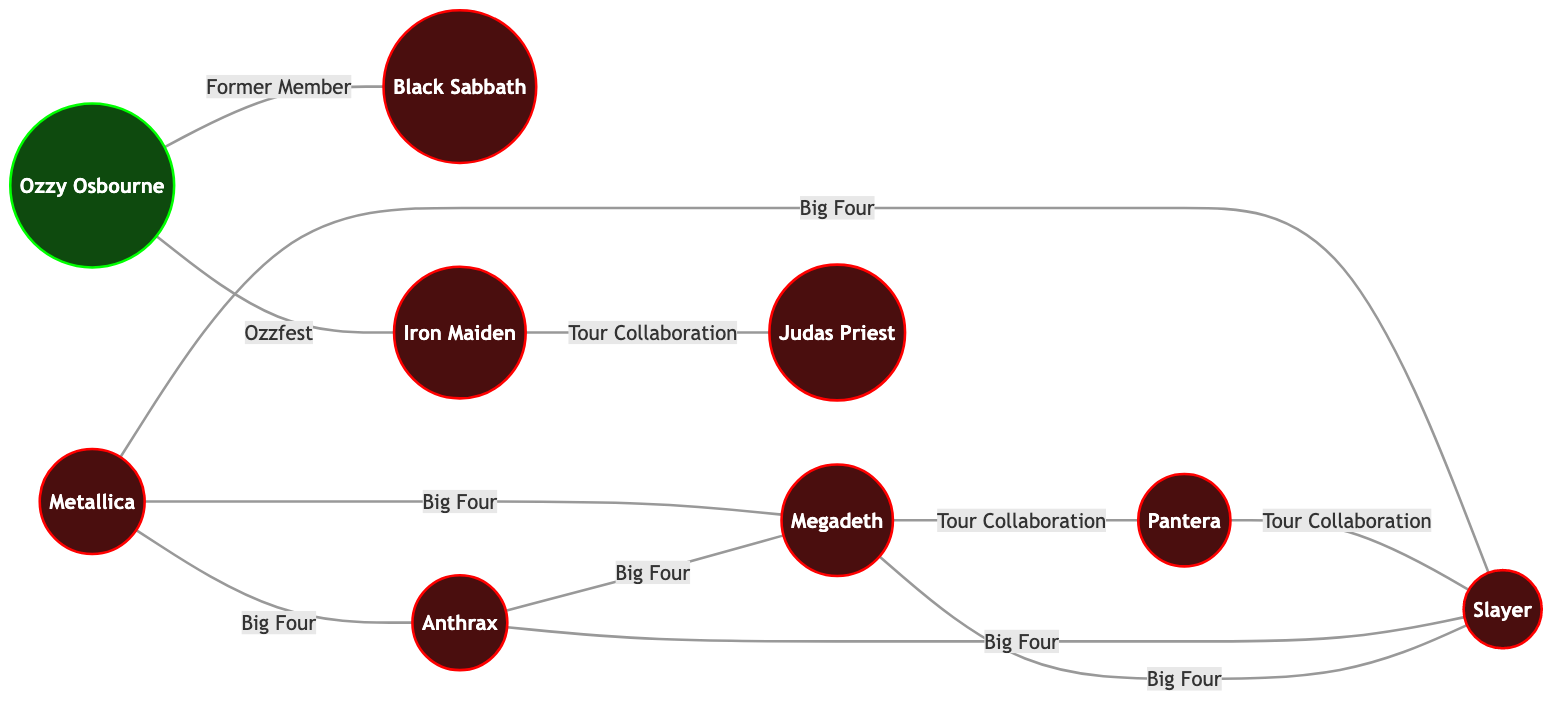What is the total number of bands in the diagram? By counting all the nodes labeled as "Band" in the diagram, which include Metallica, Black Sabbath, Iron Maiden, Slayer, Megadeth, Anthrax, and Pantera, we find there are 7 bands in total.
Answer: 7 Which band has a "Former Member" relationship with Ozzy Osbourne? By examining the edge that connects Ozzy Osbourne to another node in the diagram, we see that Black Sabbath is the band associated with the "Former Member" relationship.
Answer: Black Sabbath How many "Big Four" relationships are associated with Metallica? Looking at the edges connected to Metallica, we identify three relationships labeled "Big Four," connecting it to Anthrax, Slayer, and Megadeth.
Answer: 3 Which two bands are connected through the "Ozzfest" relationship? Checking the edge that connects Ozzy Osbourne to another node, we find that Iron Maiden is the band connected through the "Ozzfest" relationship.
Answer: Iron Maiden What type of collaboration is noted between Pantera and Slayer? By looking at the edge connecting Pantera and Slayer, we find that it is labeled as a "Tour Collaboration."
Answer: Tour Collaboration Which band is connected to Iron Maiden through a "Tour Collaboration"? The edge between Iron Maiden and another band can be examined, revealing that it is connected to Judas Priest via a "Tour Collaboration."
Answer: Judas Priest How many total edges are displayed in the diagram? Counting all the connections (edges) listed in the diagram that link the bands and solo artists, we find there are a total of 10 edges.
Answer: 10 Which band collaborates with Megadeth through both the "Big Four" and "Tour Collaboration" relationships? Upon reviewing the diagram, Pantera is the band that has connections with Megadeth through the "Big Four" and the "Tour Collaboration."
Answer: Pantera Which band is NOT connected to Slayer in any way? By analyzing each edge connected to Slayer, we see that Black Sabbath is not connected to Slayer in any represented relationship in the diagram.
Answer: Black Sabbath 